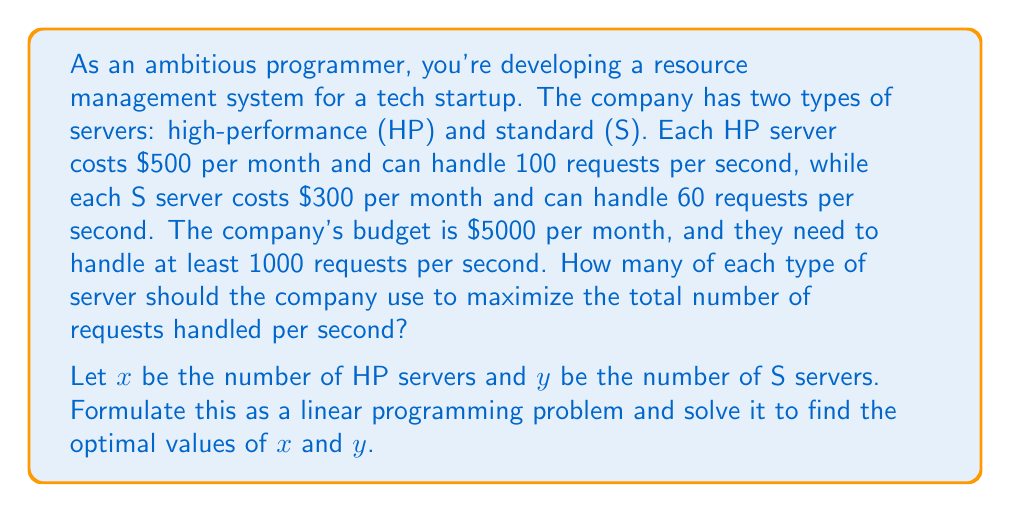What is the answer to this math problem? To solve this problem using linear programming, we need to follow these steps:

1. Define the objective function
2. Identify the constraints
3. Set up the linear programming problem
4. Solve the problem using the graphical method

Step 1: Define the objective function

We want to maximize the total number of requests handled per second:
$$ \text{Maximize } Z = 100x + 60y $$

Step 2: Identify the constraints

Budget constraint: $500x + 300y \leq 5000$
Minimum requests constraint: $100x + 60y \geq 1000$
Non-negativity constraints: $x \geq 0, y \geq 0$

Step 3: Set up the linear programming problem

$$ \text{Maximize } Z = 100x + 60y $$
$$ \text{Subject to:} $$
$$ 500x + 300y \leq 5000 $$
$$ 100x + 60y \geq 1000 $$
$$ x \geq 0, y \geq 0 $$

Step 4: Solve the problem using the graphical method

a) Plot the constraints:
   - Budget: $500x + 300y = 5000$ or $y = \frac{50}{3} - \frac{5}{3}x$
   - Minimum requests: $100x + 60y = 1000$ or $y = \frac{50}{3} - \frac{5}{3}x$

b) Identify the feasible region (the area that satisfies all constraints).

c) Find the corner points of the feasible region:
   - (0, 16.67) - intersection of y-axis and budget line
   - (10, 0) - intersection of x-axis and budget line
   - (10, 0) - intersection of x-axis and minimum requests line
   - (0, 16.67) - intersection of y-axis and minimum requests line

d) Evaluate the objective function at each corner point:
   - (0, 16.67): $Z = 100(0) + 60(16.67) = 1000$
   - (10, 0): $Z = 100(10) + 60(0) = 1000$

e) The optimal solution is at the intersection of the budget and minimum requests lines:
   Solving the system of equations:
   $$ 500x + 300y = 5000 $$
   $$ 100x + 60y = 1000 $$

   We get: $x = 6.67$ and $y = 5.56$

   Since we can't have fractional servers, we round down to the nearest integer:
   $x = 6$ and $y = 5$

f) Check if the rounded solution satisfies all constraints:
   Budget: $500(6) + 300(5) = 4500 \leq 5000$
   Minimum requests: $100(6) + 60(5) = 900 < 1000$

   The rounded solution doesn't meet the minimum requests constraint, so we need to adjust:
   $x = 7$ and $y = 5$

   Rechecking:
   Budget: $500(7) + 300(5) = 5000 \leq 5000$
   Minimum requests: $100(7) + 60(5) = 1000 \geq 1000$

   This solution satisfies all constraints and maximizes the objective function.
Answer: The optimal solution is to use 7 high-performance (HP) servers and 5 standard (S) servers. This configuration will handle a total of $100(7) + 60(5) = 1000$ requests per second, meeting the minimum requirement while staying within the budget of $5000 per month. 